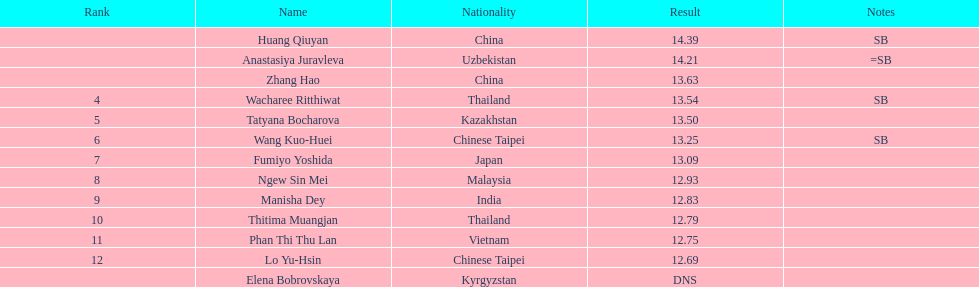How many people were ranked? 12. 